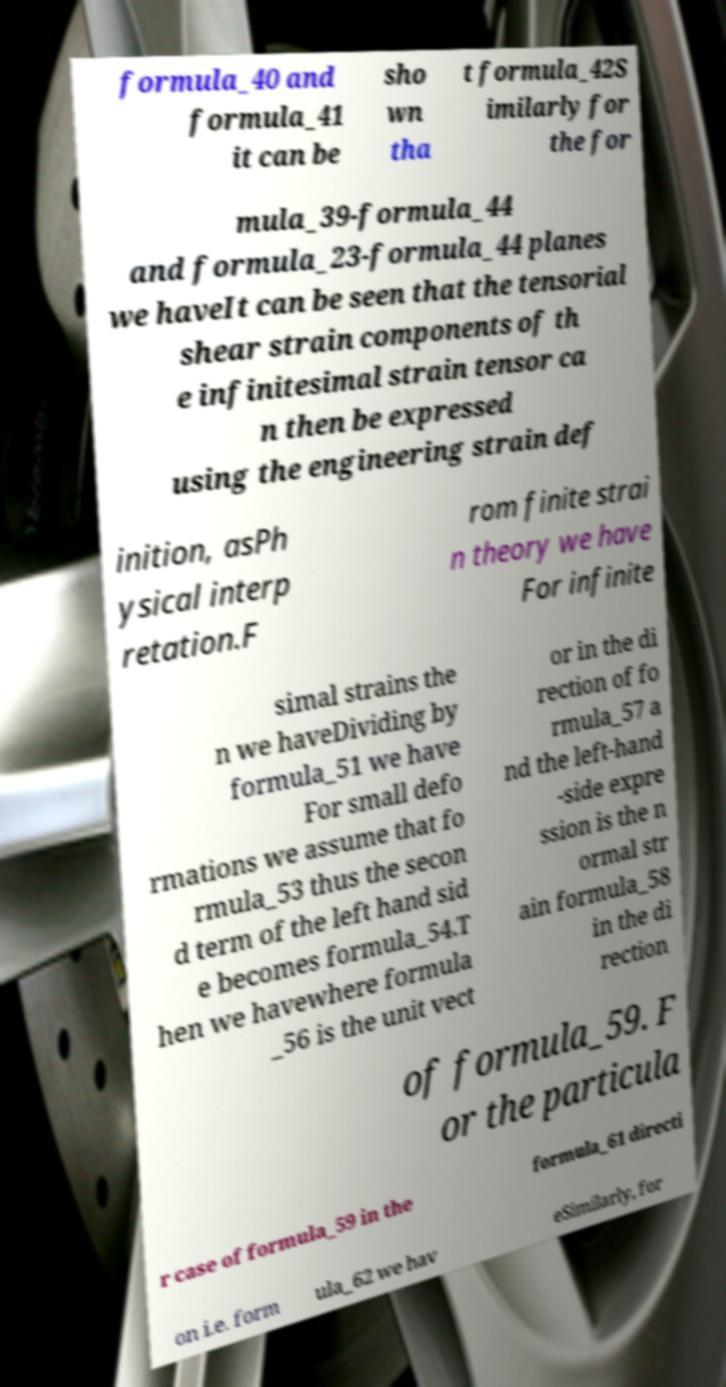Please identify and transcribe the text found in this image. formula_40 and formula_41 it can be sho wn tha t formula_42S imilarly for the for mula_39-formula_44 and formula_23-formula_44 planes we haveIt can be seen that the tensorial shear strain components of th e infinitesimal strain tensor ca n then be expressed using the engineering strain def inition, asPh ysical interp retation.F rom finite strai n theory we have For infinite simal strains the n we haveDividing by formula_51 we have For small defo rmations we assume that fo rmula_53 thus the secon d term of the left hand sid e becomes formula_54.T hen we havewhere formula _56 is the unit vect or in the di rection of fo rmula_57 a nd the left-hand -side expre ssion is the n ormal str ain formula_58 in the di rection of formula_59. F or the particula r case of formula_59 in the formula_61 directi on i.e. form ula_62 we hav eSimilarly, for 